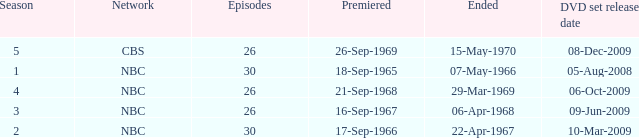When dis cbs release the DVD set? 08-Dec-2009. 